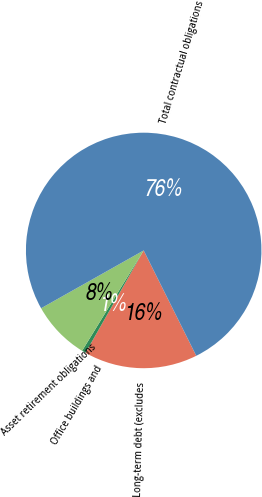<chart> <loc_0><loc_0><loc_500><loc_500><pie_chart><fcel>Long-term debt (excludes<fcel>Office buildings and<fcel>Asset retirement obligations<fcel>Total contractual obligations<nl><fcel>15.59%<fcel>0.54%<fcel>8.07%<fcel>75.8%<nl></chart> 